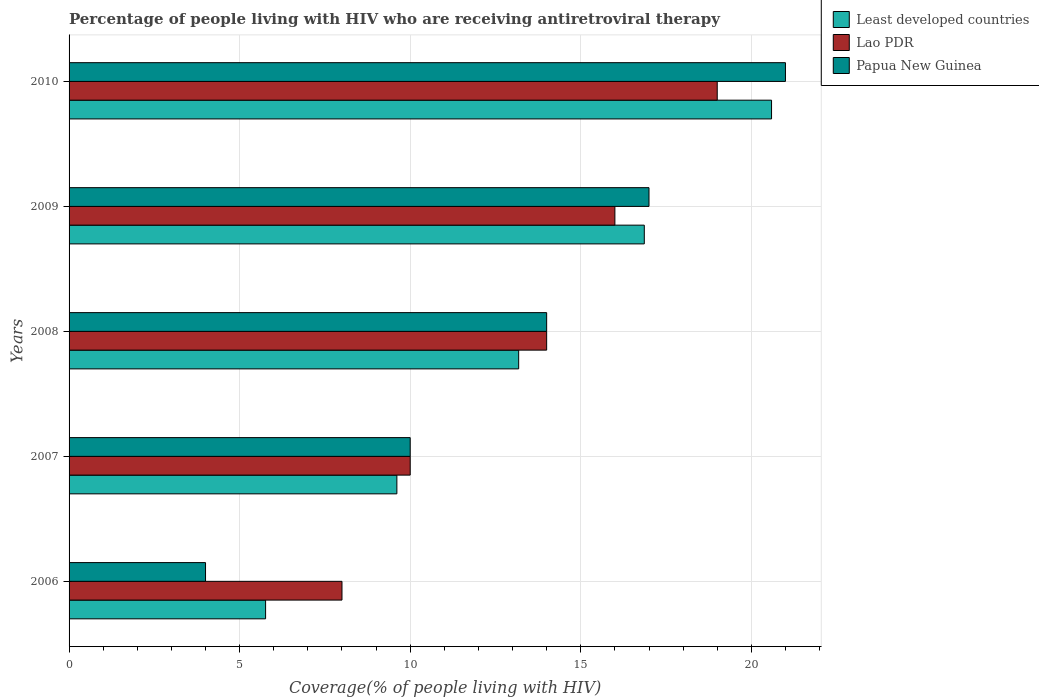How many different coloured bars are there?
Provide a short and direct response. 3. Are the number of bars on each tick of the Y-axis equal?
Your response must be concise. Yes. How many bars are there on the 2nd tick from the top?
Your response must be concise. 3. How many bars are there on the 5th tick from the bottom?
Make the answer very short. 3. What is the label of the 5th group of bars from the top?
Your answer should be compact. 2006. What is the percentage of the HIV infected people who are receiving antiretroviral therapy in Papua New Guinea in 2006?
Your answer should be very brief. 4. Across all years, what is the maximum percentage of the HIV infected people who are receiving antiretroviral therapy in Lao PDR?
Provide a short and direct response. 19. Across all years, what is the minimum percentage of the HIV infected people who are receiving antiretroviral therapy in Least developed countries?
Your answer should be compact. 5.76. In which year was the percentage of the HIV infected people who are receiving antiretroviral therapy in Lao PDR minimum?
Offer a very short reply. 2006. What is the total percentage of the HIV infected people who are receiving antiretroviral therapy in Papua New Guinea in the graph?
Provide a succinct answer. 66. What is the difference between the percentage of the HIV infected people who are receiving antiretroviral therapy in Least developed countries in 2008 and that in 2010?
Offer a very short reply. -7.41. What is the difference between the percentage of the HIV infected people who are receiving antiretroviral therapy in Papua New Guinea in 2006 and the percentage of the HIV infected people who are receiving antiretroviral therapy in Lao PDR in 2009?
Provide a succinct answer. -12. In the year 2008, what is the difference between the percentage of the HIV infected people who are receiving antiretroviral therapy in Lao PDR and percentage of the HIV infected people who are receiving antiretroviral therapy in Least developed countries?
Your answer should be very brief. 0.82. What is the ratio of the percentage of the HIV infected people who are receiving antiretroviral therapy in Papua New Guinea in 2006 to that in 2009?
Your answer should be compact. 0.24. What is the difference between the highest and the second highest percentage of the HIV infected people who are receiving antiretroviral therapy in Least developed countries?
Your answer should be compact. 3.73. What is the difference between the highest and the lowest percentage of the HIV infected people who are receiving antiretroviral therapy in Least developed countries?
Make the answer very short. 14.83. Is the sum of the percentage of the HIV infected people who are receiving antiretroviral therapy in Least developed countries in 2007 and 2010 greater than the maximum percentage of the HIV infected people who are receiving antiretroviral therapy in Papua New Guinea across all years?
Keep it short and to the point. Yes. What does the 3rd bar from the top in 2009 represents?
Offer a very short reply. Least developed countries. What does the 3rd bar from the bottom in 2007 represents?
Offer a terse response. Papua New Guinea. Is it the case that in every year, the sum of the percentage of the HIV infected people who are receiving antiretroviral therapy in Lao PDR and percentage of the HIV infected people who are receiving antiretroviral therapy in Papua New Guinea is greater than the percentage of the HIV infected people who are receiving antiretroviral therapy in Least developed countries?
Your answer should be compact. Yes. How many bars are there?
Provide a short and direct response. 15. Are all the bars in the graph horizontal?
Offer a terse response. Yes. Where does the legend appear in the graph?
Make the answer very short. Top right. How many legend labels are there?
Make the answer very short. 3. How are the legend labels stacked?
Make the answer very short. Vertical. What is the title of the graph?
Offer a very short reply. Percentage of people living with HIV who are receiving antiretroviral therapy. Does "Liberia" appear as one of the legend labels in the graph?
Keep it short and to the point. No. What is the label or title of the X-axis?
Your response must be concise. Coverage(% of people living with HIV). What is the Coverage(% of people living with HIV) in Least developed countries in 2006?
Your answer should be very brief. 5.76. What is the Coverage(% of people living with HIV) of Lao PDR in 2006?
Offer a very short reply. 8. What is the Coverage(% of people living with HIV) in Papua New Guinea in 2006?
Provide a short and direct response. 4. What is the Coverage(% of people living with HIV) of Least developed countries in 2007?
Keep it short and to the point. 9.61. What is the Coverage(% of people living with HIV) of Papua New Guinea in 2007?
Make the answer very short. 10. What is the Coverage(% of people living with HIV) in Least developed countries in 2008?
Your answer should be compact. 13.18. What is the Coverage(% of people living with HIV) in Lao PDR in 2008?
Your answer should be very brief. 14. What is the Coverage(% of people living with HIV) of Papua New Guinea in 2008?
Offer a terse response. 14. What is the Coverage(% of people living with HIV) in Least developed countries in 2009?
Offer a terse response. 16.86. What is the Coverage(% of people living with HIV) in Papua New Guinea in 2009?
Offer a very short reply. 17. What is the Coverage(% of people living with HIV) in Least developed countries in 2010?
Make the answer very short. 20.59. Across all years, what is the maximum Coverage(% of people living with HIV) in Least developed countries?
Keep it short and to the point. 20.59. Across all years, what is the minimum Coverage(% of people living with HIV) in Least developed countries?
Provide a short and direct response. 5.76. What is the total Coverage(% of people living with HIV) in Least developed countries in the graph?
Provide a succinct answer. 66. What is the difference between the Coverage(% of people living with HIV) of Least developed countries in 2006 and that in 2007?
Your response must be concise. -3.85. What is the difference between the Coverage(% of people living with HIV) in Papua New Guinea in 2006 and that in 2007?
Your answer should be very brief. -6. What is the difference between the Coverage(% of people living with HIV) in Least developed countries in 2006 and that in 2008?
Give a very brief answer. -7.42. What is the difference between the Coverage(% of people living with HIV) of Least developed countries in 2006 and that in 2009?
Ensure brevity in your answer.  -11.1. What is the difference between the Coverage(% of people living with HIV) of Lao PDR in 2006 and that in 2009?
Offer a terse response. -8. What is the difference between the Coverage(% of people living with HIV) of Papua New Guinea in 2006 and that in 2009?
Offer a very short reply. -13. What is the difference between the Coverage(% of people living with HIV) of Least developed countries in 2006 and that in 2010?
Ensure brevity in your answer.  -14.83. What is the difference between the Coverage(% of people living with HIV) of Least developed countries in 2007 and that in 2008?
Give a very brief answer. -3.57. What is the difference between the Coverage(% of people living with HIV) of Papua New Guinea in 2007 and that in 2008?
Offer a terse response. -4. What is the difference between the Coverage(% of people living with HIV) of Least developed countries in 2007 and that in 2009?
Ensure brevity in your answer.  -7.25. What is the difference between the Coverage(% of people living with HIV) of Lao PDR in 2007 and that in 2009?
Keep it short and to the point. -6. What is the difference between the Coverage(% of people living with HIV) in Papua New Guinea in 2007 and that in 2009?
Provide a short and direct response. -7. What is the difference between the Coverage(% of people living with HIV) of Least developed countries in 2007 and that in 2010?
Make the answer very short. -10.98. What is the difference between the Coverage(% of people living with HIV) of Lao PDR in 2007 and that in 2010?
Offer a very short reply. -9. What is the difference between the Coverage(% of people living with HIV) of Papua New Guinea in 2007 and that in 2010?
Ensure brevity in your answer.  -11. What is the difference between the Coverage(% of people living with HIV) in Least developed countries in 2008 and that in 2009?
Make the answer very short. -3.68. What is the difference between the Coverage(% of people living with HIV) of Papua New Guinea in 2008 and that in 2009?
Provide a succinct answer. -3. What is the difference between the Coverage(% of people living with HIV) of Least developed countries in 2008 and that in 2010?
Make the answer very short. -7.41. What is the difference between the Coverage(% of people living with HIV) of Papua New Guinea in 2008 and that in 2010?
Your answer should be very brief. -7. What is the difference between the Coverage(% of people living with HIV) of Least developed countries in 2009 and that in 2010?
Give a very brief answer. -3.73. What is the difference between the Coverage(% of people living with HIV) of Papua New Guinea in 2009 and that in 2010?
Offer a very short reply. -4. What is the difference between the Coverage(% of people living with HIV) of Least developed countries in 2006 and the Coverage(% of people living with HIV) of Lao PDR in 2007?
Your response must be concise. -4.24. What is the difference between the Coverage(% of people living with HIV) of Least developed countries in 2006 and the Coverage(% of people living with HIV) of Papua New Guinea in 2007?
Provide a short and direct response. -4.24. What is the difference between the Coverage(% of people living with HIV) in Lao PDR in 2006 and the Coverage(% of people living with HIV) in Papua New Guinea in 2007?
Ensure brevity in your answer.  -2. What is the difference between the Coverage(% of people living with HIV) in Least developed countries in 2006 and the Coverage(% of people living with HIV) in Lao PDR in 2008?
Offer a very short reply. -8.24. What is the difference between the Coverage(% of people living with HIV) of Least developed countries in 2006 and the Coverage(% of people living with HIV) of Papua New Guinea in 2008?
Your answer should be very brief. -8.24. What is the difference between the Coverage(% of people living with HIV) of Least developed countries in 2006 and the Coverage(% of people living with HIV) of Lao PDR in 2009?
Your answer should be very brief. -10.24. What is the difference between the Coverage(% of people living with HIV) in Least developed countries in 2006 and the Coverage(% of people living with HIV) in Papua New Guinea in 2009?
Offer a terse response. -11.24. What is the difference between the Coverage(% of people living with HIV) of Lao PDR in 2006 and the Coverage(% of people living with HIV) of Papua New Guinea in 2009?
Make the answer very short. -9. What is the difference between the Coverage(% of people living with HIV) in Least developed countries in 2006 and the Coverage(% of people living with HIV) in Lao PDR in 2010?
Keep it short and to the point. -13.24. What is the difference between the Coverage(% of people living with HIV) of Least developed countries in 2006 and the Coverage(% of people living with HIV) of Papua New Guinea in 2010?
Your response must be concise. -15.24. What is the difference between the Coverage(% of people living with HIV) in Lao PDR in 2006 and the Coverage(% of people living with HIV) in Papua New Guinea in 2010?
Ensure brevity in your answer.  -13. What is the difference between the Coverage(% of people living with HIV) of Least developed countries in 2007 and the Coverage(% of people living with HIV) of Lao PDR in 2008?
Ensure brevity in your answer.  -4.39. What is the difference between the Coverage(% of people living with HIV) of Least developed countries in 2007 and the Coverage(% of people living with HIV) of Papua New Guinea in 2008?
Your answer should be very brief. -4.39. What is the difference between the Coverage(% of people living with HIV) in Least developed countries in 2007 and the Coverage(% of people living with HIV) in Lao PDR in 2009?
Offer a very short reply. -6.39. What is the difference between the Coverage(% of people living with HIV) in Least developed countries in 2007 and the Coverage(% of people living with HIV) in Papua New Guinea in 2009?
Your answer should be very brief. -7.39. What is the difference between the Coverage(% of people living with HIV) of Lao PDR in 2007 and the Coverage(% of people living with HIV) of Papua New Guinea in 2009?
Offer a terse response. -7. What is the difference between the Coverage(% of people living with HIV) in Least developed countries in 2007 and the Coverage(% of people living with HIV) in Lao PDR in 2010?
Provide a succinct answer. -9.39. What is the difference between the Coverage(% of people living with HIV) of Least developed countries in 2007 and the Coverage(% of people living with HIV) of Papua New Guinea in 2010?
Offer a very short reply. -11.39. What is the difference between the Coverage(% of people living with HIV) in Least developed countries in 2008 and the Coverage(% of people living with HIV) in Lao PDR in 2009?
Provide a short and direct response. -2.82. What is the difference between the Coverage(% of people living with HIV) of Least developed countries in 2008 and the Coverage(% of people living with HIV) of Papua New Guinea in 2009?
Keep it short and to the point. -3.82. What is the difference between the Coverage(% of people living with HIV) in Lao PDR in 2008 and the Coverage(% of people living with HIV) in Papua New Guinea in 2009?
Offer a terse response. -3. What is the difference between the Coverage(% of people living with HIV) in Least developed countries in 2008 and the Coverage(% of people living with HIV) in Lao PDR in 2010?
Offer a very short reply. -5.82. What is the difference between the Coverage(% of people living with HIV) of Least developed countries in 2008 and the Coverage(% of people living with HIV) of Papua New Guinea in 2010?
Keep it short and to the point. -7.82. What is the difference between the Coverage(% of people living with HIV) of Lao PDR in 2008 and the Coverage(% of people living with HIV) of Papua New Guinea in 2010?
Provide a succinct answer. -7. What is the difference between the Coverage(% of people living with HIV) in Least developed countries in 2009 and the Coverage(% of people living with HIV) in Lao PDR in 2010?
Make the answer very short. -2.14. What is the difference between the Coverage(% of people living with HIV) in Least developed countries in 2009 and the Coverage(% of people living with HIV) in Papua New Guinea in 2010?
Offer a very short reply. -4.14. What is the average Coverage(% of people living with HIV) in Least developed countries per year?
Provide a succinct answer. 13.2. In the year 2006, what is the difference between the Coverage(% of people living with HIV) of Least developed countries and Coverage(% of people living with HIV) of Lao PDR?
Your answer should be very brief. -2.24. In the year 2006, what is the difference between the Coverage(% of people living with HIV) of Least developed countries and Coverage(% of people living with HIV) of Papua New Guinea?
Offer a very short reply. 1.76. In the year 2006, what is the difference between the Coverage(% of people living with HIV) in Lao PDR and Coverage(% of people living with HIV) in Papua New Guinea?
Your answer should be compact. 4. In the year 2007, what is the difference between the Coverage(% of people living with HIV) in Least developed countries and Coverage(% of people living with HIV) in Lao PDR?
Offer a terse response. -0.39. In the year 2007, what is the difference between the Coverage(% of people living with HIV) in Least developed countries and Coverage(% of people living with HIV) in Papua New Guinea?
Make the answer very short. -0.39. In the year 2008, what is the difference between the Coverage(% of people living with HIV) of Least developed countries and Coverage(% of people living with HIV) of Lao PDR?
Ensure brevity in your answer.  -0.82. In the year 2008, what is the difference between the Coverage(% of people living with HIV) in Least developed countries and Coverage(% of people living with HIV) in Papua New Guinea?
Give a very brief answer. -0.82. In the year 2008, what is the difference between the Coverage(% of people living with HIV) of Lao PDR and Coverage(% of people living with HIV) of Papua New Guinea?
Give a very brief answer. 0. In the year 2009, what is the difference between the Coverage(% of people living with HIV) of Least developed countries and Coverage(% of people living with HIV) of Lao PDR?
Your response must be concise. 0.86. In the year 2009, what is the difference between the Coverage(% of people living with HIV) of Least developed countries and Coverage(% of people living with HIV) of Papua New Guinea?
Make the answer very short. -0.14. In the year 2010, what is the difference between the Coverage(% of people living with HIV) of Least developed countries and Coverage(% of people living with HIV) of Lao PDR?
Your answer should be compact. 1.59. In the year 2010, what is the difference between the Coverage(% of people living with HIV) of Least developed countries and Coverage(% of people living with HIV) of Papua New Guinea?
Your answer should be compact. -0.41. What is the ratio of the Coverage(% of people living with HIV) of Least developed countries in 2006 to that in 2007?
Offer a terse response. 0.6. What is the ratio of the Coverage(% of people living with HIV) in Lao PDR in 2006 to that in 2007?
Keep it short and to the point. 0.8. What is the ratio of the Coverage(% of people living with HIV) of Least developed countries in 2006 to that in 2008?
Your answer should be very brief. 0.44. What is the ratio of the Coverage(% of people living with HIV) of Papua New Guinea in 2006 to that in 2008?
Offer a very short reply. 0.29. What is the ratio of the Coverage(% of people living with HIV) in Least developed countries in 2006 to that in 2009?
Provide a succinct answer. 0.34. What is the ratio of the Coverage(% of people living with HIV) of Papua New Guinea in 2006 to that in 2009?
Provide a short and direct response. 0.24. What is the ratio of the Coverage(% of people living with HIV) in Least developed countries in 2006 to that in 2010?
Provide a succinct answer. 0.28. What is the ratio of the Coverage(% of people living with HIV) of Lao PDR in 2006 to that in 2010?
Make the answer very short. 0.42. What is the ratio of the Coverage(% of people living with HIV) in Papua New Guinea in 2006 to that in 2010?
Make the answer very short. 0.19. What is the ratio of the Coverage(% of people living with HIV) in Least developed countries in 2007 to that in 2008?
Your answer should be very brief. 0.73. What is the ratio of the Coverage(% of people living with HIV) in Lao PDR in 2007 to that in 2008?
Give a very brief answer. 0.71. What is the ratio of the Coverage(% of people living with HIV) in Papua New Guinea in 2007 to that in 2008?
Your answer should be compact. 0.71. What is the ratio of the Coverage(% of people living with HIV) in Least developed countries in 2007 to that in 2009?
Your answer should be very brief. 0.57. What is the ratio of the Coverage(% of people living with HIV) in Lao PDR in 2007 to that in 2009?
Ensure brevity in your answer.  0.62. What is the ratio of the Coverage(% of people living with HIV) of Papua New Guinea in 2007 to that in 2009?
Offer a terse response. 0.59. What is the ratio of the Coverage(% of people living with HIV) in Least developed countries in 2007 to that in 2010?
Provide a short and direct response. 0.47. What is the ratio of the Coverage(% of people living with HIV) in Lao PDR in 2007 to that in 2010?
Your answer should be compact. 0.53. What is the ratio of the Coverage(% of people living with HIV) in Papua New Guinea in 2007 to that in 2010?
Your response must be concise. 0.48. What is the ratio of the Coverage(% of people living with HIV) of Least developed countries in 2008 to that in 2009?
Offer a very short reply. 0.78. What is the ratio of the Coverage(% of people living with HIV) in Lao PDR in 2008 to that in 2009?
Your response must be concise. 0.88. What is the ratio of the Coverage(% of people living with HIV) in Papua New Guinea in 2008 to that in 2009?
Provide a succinct answer. 0.82. What is the ratio of the Coverage(% of people living with HIV) in Least developed countries in 2008 to that in 2010?
Keep it short and to the point. 0.64. What is the ratio of the Coverage(% of people living with HIV) in Lao PDR in 2008 to that in 2010?
Your answer should be very brief. 0.74. What is the ratio of the Coverage(% of people living with HIV) of Least developed countries in 2009 to that in 2010?
Ensure brevity in your answer.  0.82. What is the ratio of the Coverage(% of people living with HIV) of Lao PDR in 2009 to that in 2010?
Your response must be concise. 0.84. What is the ratio of the Coverage(% of people living with HIV) in Papua New Guinea in 2009 to that in 2010?
Keep it short and to the point. 0.81. What is the difference between the highest and the second highest Coverage(% of people living with HIV) of Least developed countries?
Offer a very short reply. 3.73. What is the difference between the highest and the second highest Coverage(% of people living with HIV) in Lao PDR?
Offer a terse response. 3. What is the difference between the highest and the second highest Coverage(% of people living with HIV) in Papua New Guinea?
Offer a very short reply. 4. What is the difference between the highest and the lowest Coverage(% of people living with HIV) of Least developed countries?
Offer a very short reply. 14.83. 